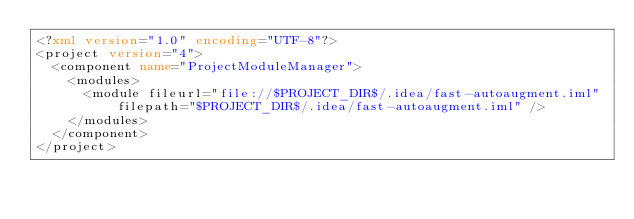Convert code to text. <code><loc_0><loc_0><loc_500><loc_500><_XML_><?xml version="1.0" encoding="UTF-8"?>
<project version="4">
  <component name="ProjectModuleManager">
    <modules>
      <module fileurl="file://$PROJECT_DIR$/.idea/fast-autoaugment.iml" filepath="$PROJECT_DIR$/.idea/fast-autoaugment.iml" />
    </modules>
  </component>
</project></code> 